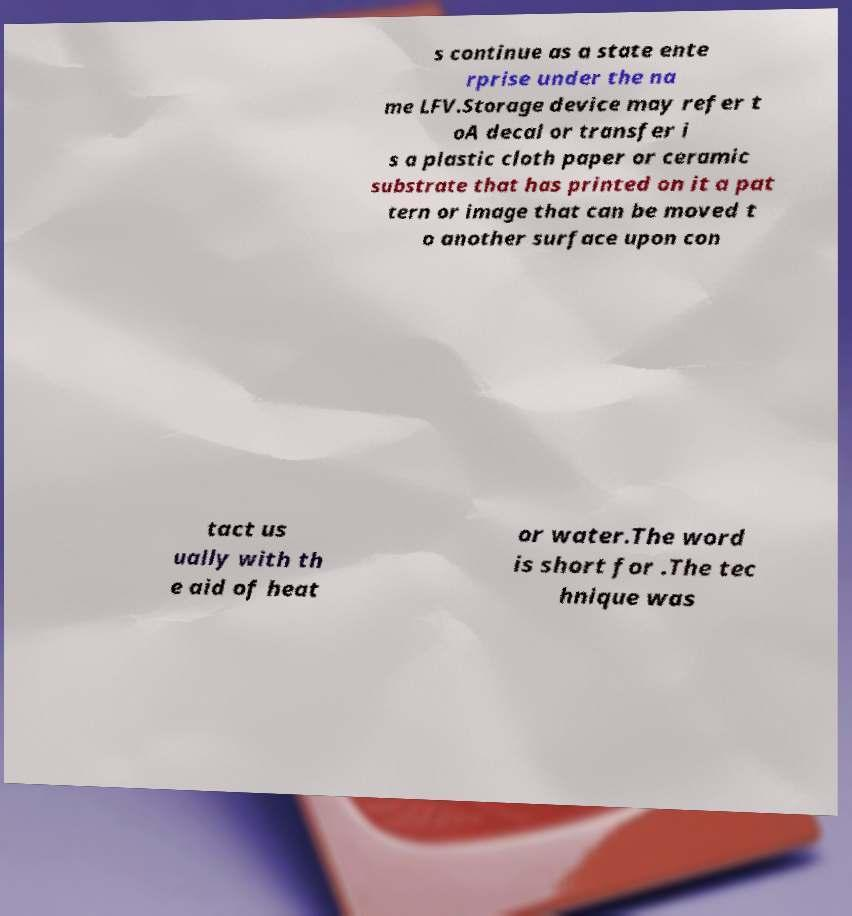Please read and relay the text visible in this image. What does it say? s continue as a state ente rprise under the na me LFV.Storage device may refer t oA decal or transfer i s a plastic cloth paper or ceramic substrate that has printed on it a pat tern or image that can be moved t o another surface upon con tact us ually with th e aid of heat or water.The word is short for .The tec hnique was 